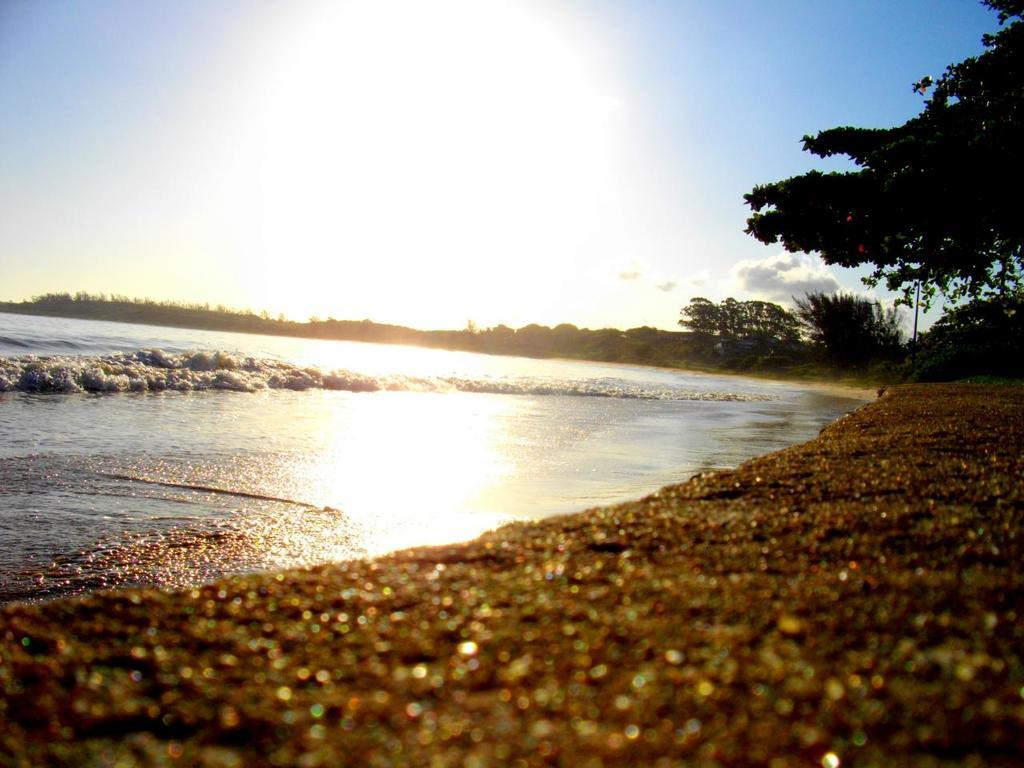What type of natural environment is depicted in the image? The image appears to depict a beach. What two elements are commonly found at a beach? There is water and sand in the image. What type of vegetation can be seen in the image? There are trees and plants in the image. What is visible in the sky in the image? The sky is visible in the image. What type of stamp can be seen on the bear's forehead in the image? There is no bear or stamp present in the image. How does the bear's cough affect the plants in the image? There is no bear or cough present in the image, so it cannot affect the plants. 